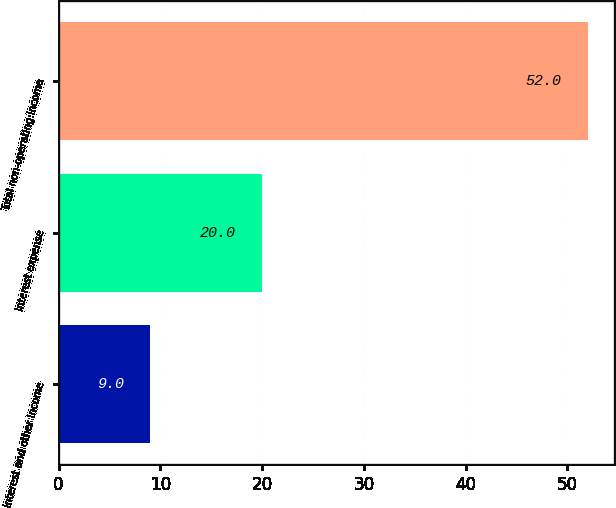Convert chart. <chart><loc_0><loc_0><loc_500><loc_500><bar_chart><fcel>Interest and other income<fcel>Interest expense<fcel>Total non-operating income<nl><fcel>9<fcel>20<fcel>52<nl></chart> 